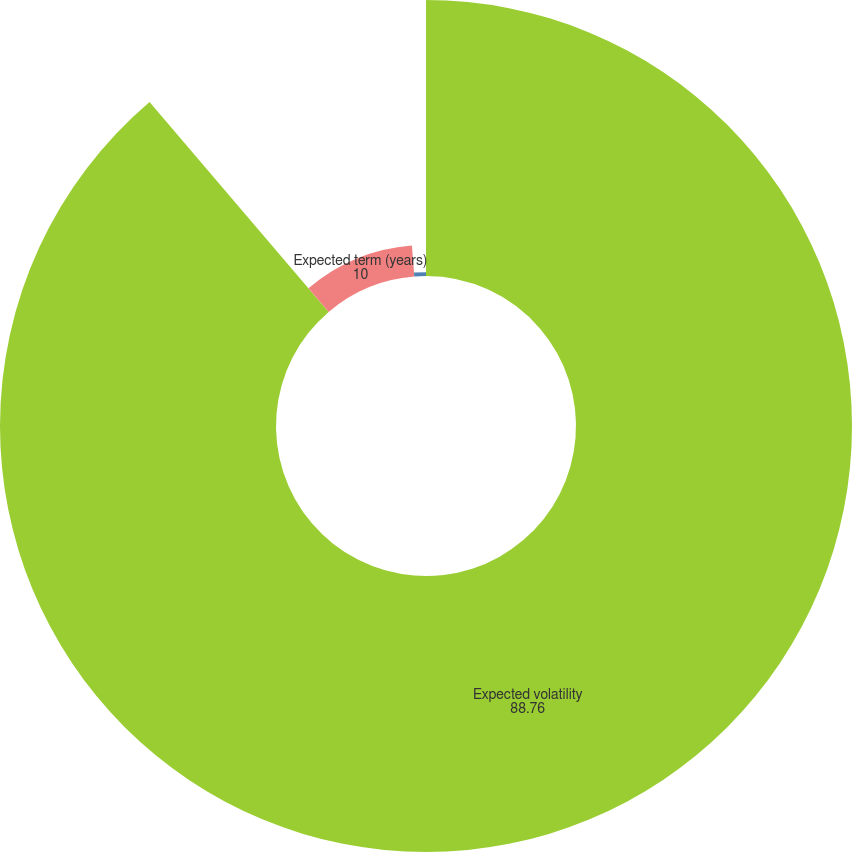Convert chart. <chart><loc_0><loc_0><loc_500><loc_500><pie_chart><fcel>Expected volatility<fcel>Expected term (years)<fcel>Risk free interest rate<nl><fcel>88.76%<fcel>10.0%<fcel>1.24%<nl></chart> 